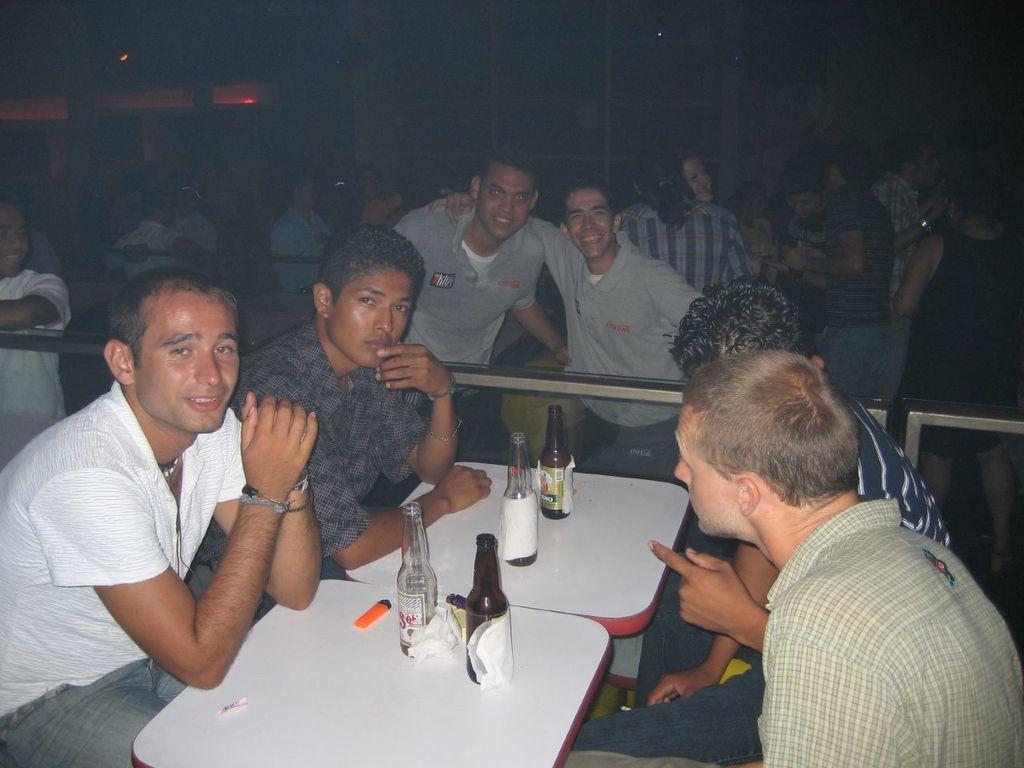Describe this image in one or two sentences. in the picture we can see some of the sitting and some persons are standing near the table,here on the table we can see bottles which are empty and also some tissue papers. 